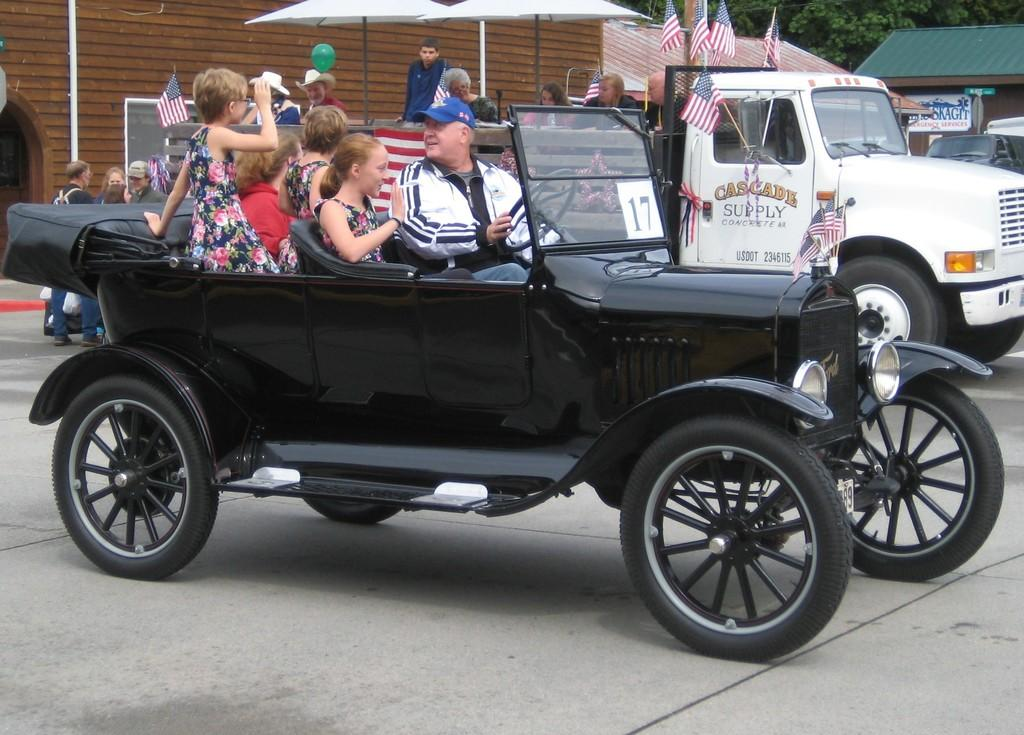What color is the car that has people inside in the image? There is a black car in the image with five people inside. Are there any other cars in the image? Yes, there is a white car in the image. What is happening with the people in the white car? There is a group of people in the white car. What type of record is being played by the fairies in the image? There are no fairies or records present in the image. Is there a doctor in the image? There is no mention of a doctor in the image. 